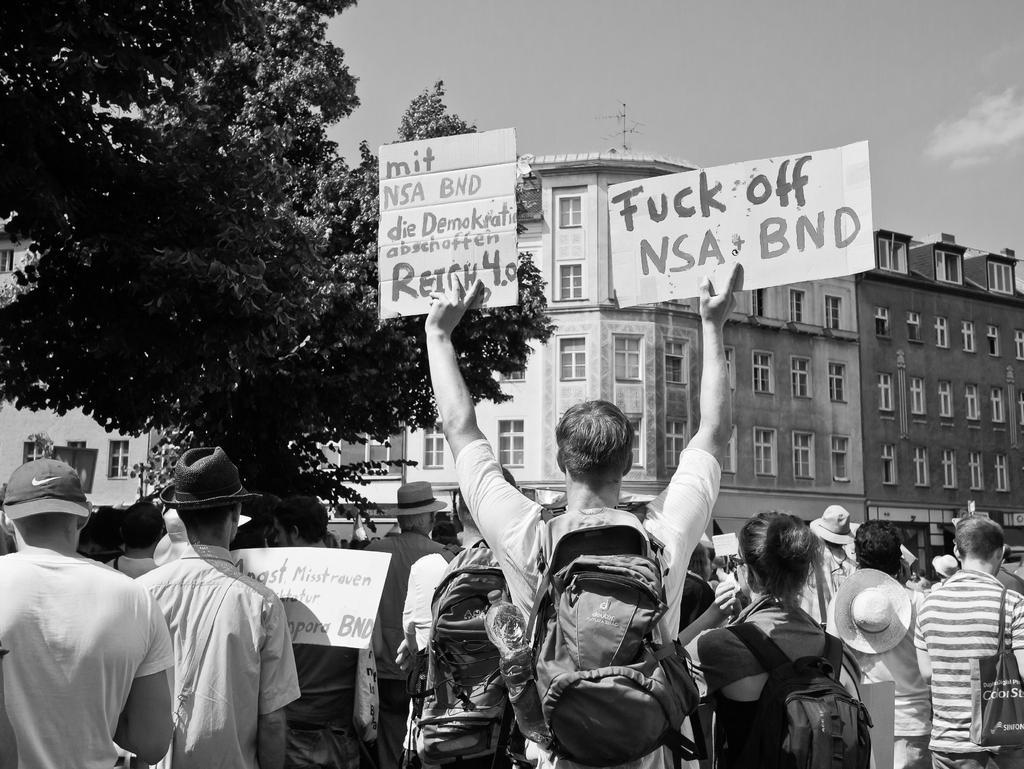Can you describe this image briefly? This picture is in black and white. At the bottom, there are people facing backwards. In the center, there is a person wearing a bag and holding boards in his hands. In each board, there is some text. Beside him, there is a woman carrying a bag. In the background, there is a building, trees and a sky. 